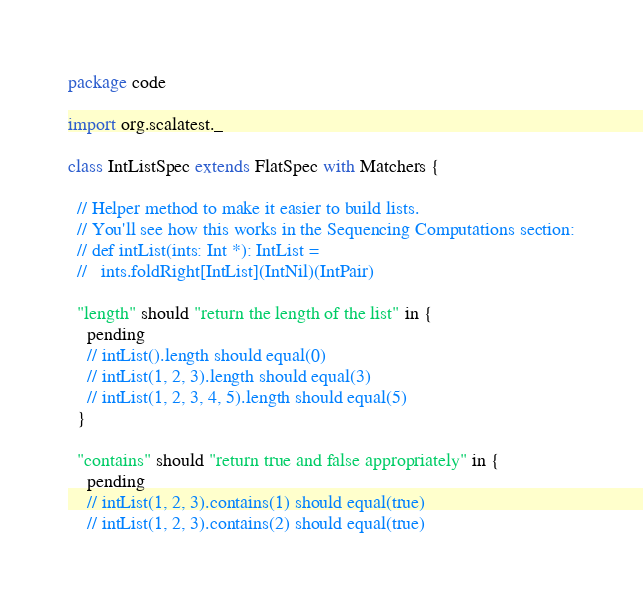Convert code to text. <code><loc_0><loc_0><loc_500><loc_500><_Scala_>package code

import org.scalatest._

class IntListSpec extends FlatSpec with Matchers {

  // Helper method to make it easier to build lists.
  // You'll see how this works in the Sequencing Computations section:
  // def intList(ints: Int *): IntList =
  //   ints.foldRight[IntList](IntNil)(IntPair)

  "length" should "return the length of the list" in {
    pending
    // intList().length should equal(0)
    // intList(1, 2, 3).length should equal(3)
    // intList(1, 2, 3, 4, 5).length should equal(5)
  }

  "contains" should "return true and false appropriately" in {
    pending
    // intList(1, 2, 3).contains(1) should equal(true)
    // intList(1, 2, 3).contains(2) should equal(true)</code> 